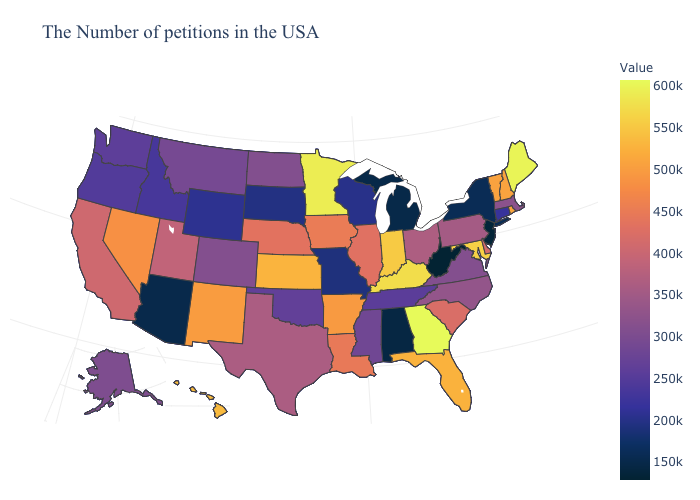Does West Virginia have the lowest value in the South?
Give a very brief answer. Yes. Among the states that border Alabama , which have the highest value?
Answer briefly. Georgia. Which states have the lowest value in the USA?
Answer briefly. West Virginia. 